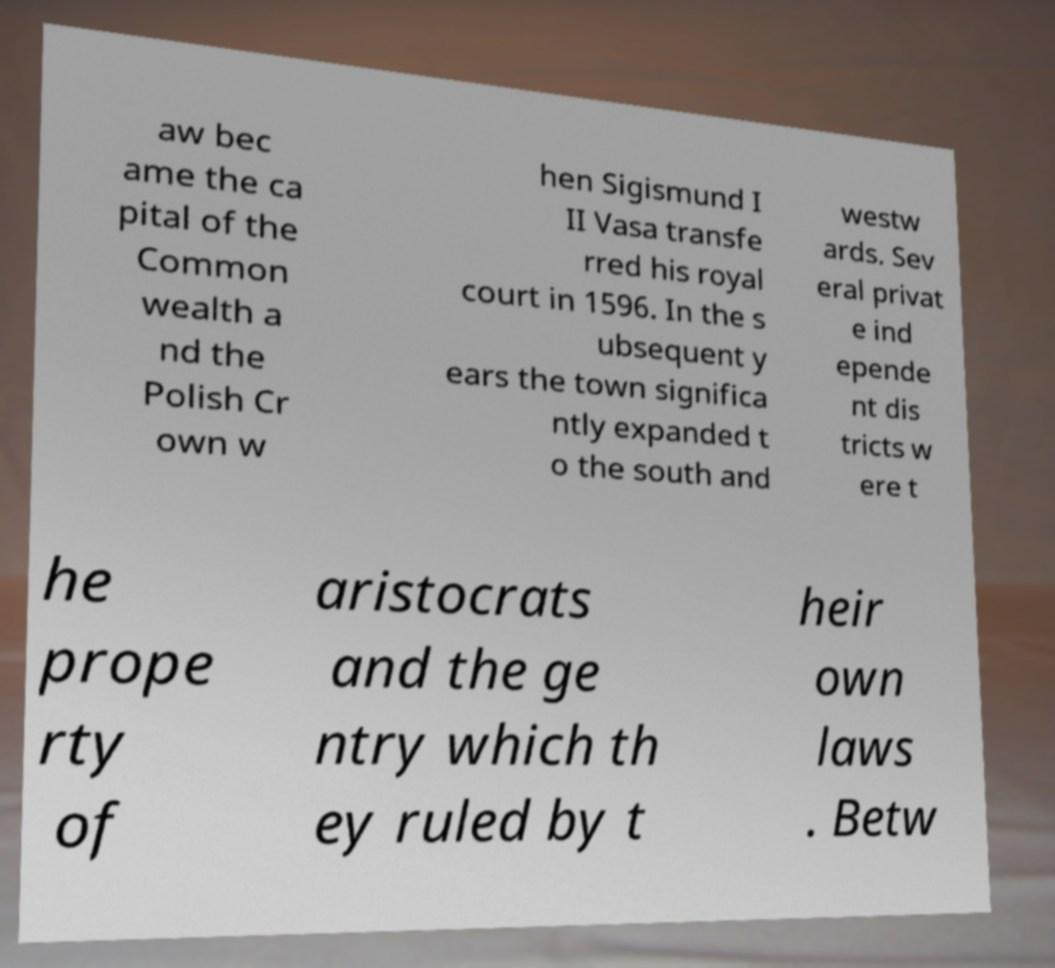Can you read and provide the text displayed in the image?This photo seems to have some interesting text. Can you extract and type it out for me? aw bec ame the ca pital of the Common wealth a nd the Polish Cr own w hen Sigismund I II Vasa transfe rred his royal court in 1596. In the s ubsequent y ears the town significa ntly expanded t o the south and westw ards. Sev eral privat e ind epende nt dis tricts w ere t he prope rty of aristocrats and the ge ntry which th ey ruled by t heir own laws . Betw 